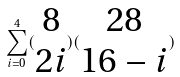Convert formula to latex. <formula><loc_0><loc_0><loc_500><loc_500>\sum _ { i = 0 } ^ { 4 } ( \begin{matrix} 8 \\ 2 i \end{matrix} ) ( \begin{matrix} 2 8 \\ 1 6 - i \end{matrix} )</formula> 